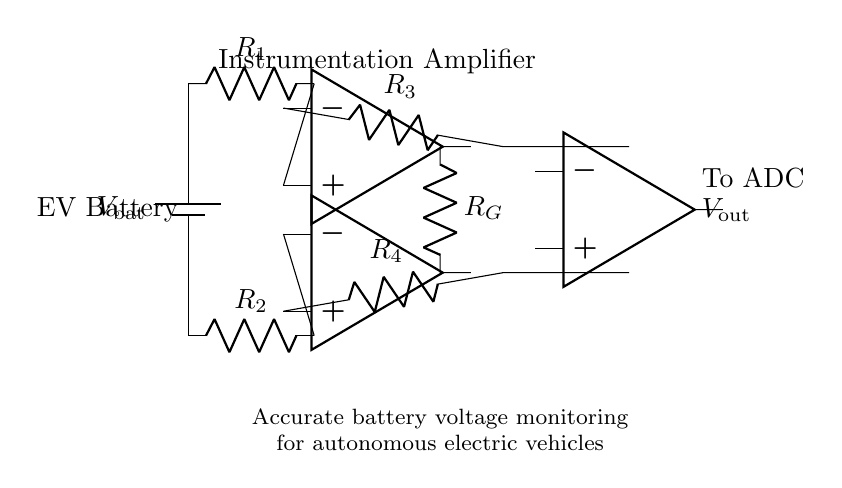What is the type of amplifier used in this circuit? The circuit features an instrumentation amplifier, identified by the two operational amplifiers at the top. They are configured for high input impedance and differential signal amplification.
Answer: instrumentation amplifier What is the function of the resistors labeled R1 and R2? R1 and R2 serve as input resistors that establish the gain of the instrument amplifier by controlling the voltage differential applied to the operational amplifiers.
Answer: input resistors How many operational amplifiers are present in this circuit? The circuit diagram contains three operational amplifiers, designated as opamp1, opamp2, and opamp3. Both opamp1 and opamp2 form the core of the instrumentation amplifier, while opamp3 is used for further processing.
Answer: three What is the role of the resistor labeled RG? RG is the gain resistor used to adjust the gain of the instrumentation amplifier, which directly influences the output voltage relative to the differential input voltage from the battery.
Answer: gain resistor What does Vout represent in this circuit? Vout is the output voltage of the instrumentation amplifier that is sent to the analog-to-digital converter (ADC) for digital processing and monitoring of the battery voltage.
Answer: output voltage What is the expected behavior of the circuit regarding battery voltage monitoring? The circuit accurately monitors battery voltage by amplifying the differential voltage between the battery terminals, facilitating precise readings even with low battery levels.
Answer: accurate voltage monitoring 